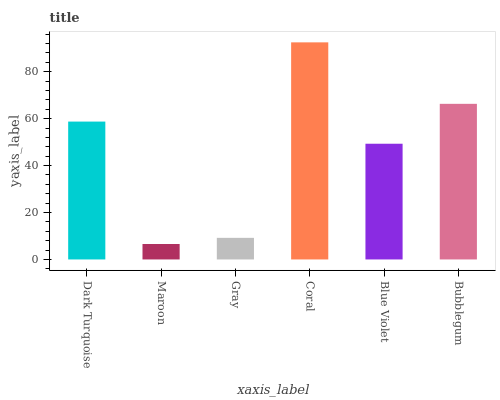Is Maroon the minimum?
Answer yes or no. Yes. Is Coral the maximum?
Answer yes or no. Yes. Is Gray the minimum?
Answer yes or no. No. Is Gray the maximum?
Answer yes or no. No. Is Gray greater than Maroon?
Answer yes or no. Yes. Is Maroon less than Gray?
Answer yes or no. Yes. Is Maroon greater than Gray?
Answer yes or no. No. Is Gray less than Maroon?
Answer yes or no. No. Is Dark Turquoise the high median?
Answer yes or no. Yes. Is Blue Violet the low median?
Answer yes or no. Yes. Is Maroon the high median?
Answer yes or no. No. Is Bubblegum the low median?
Answer yes or no. No. 